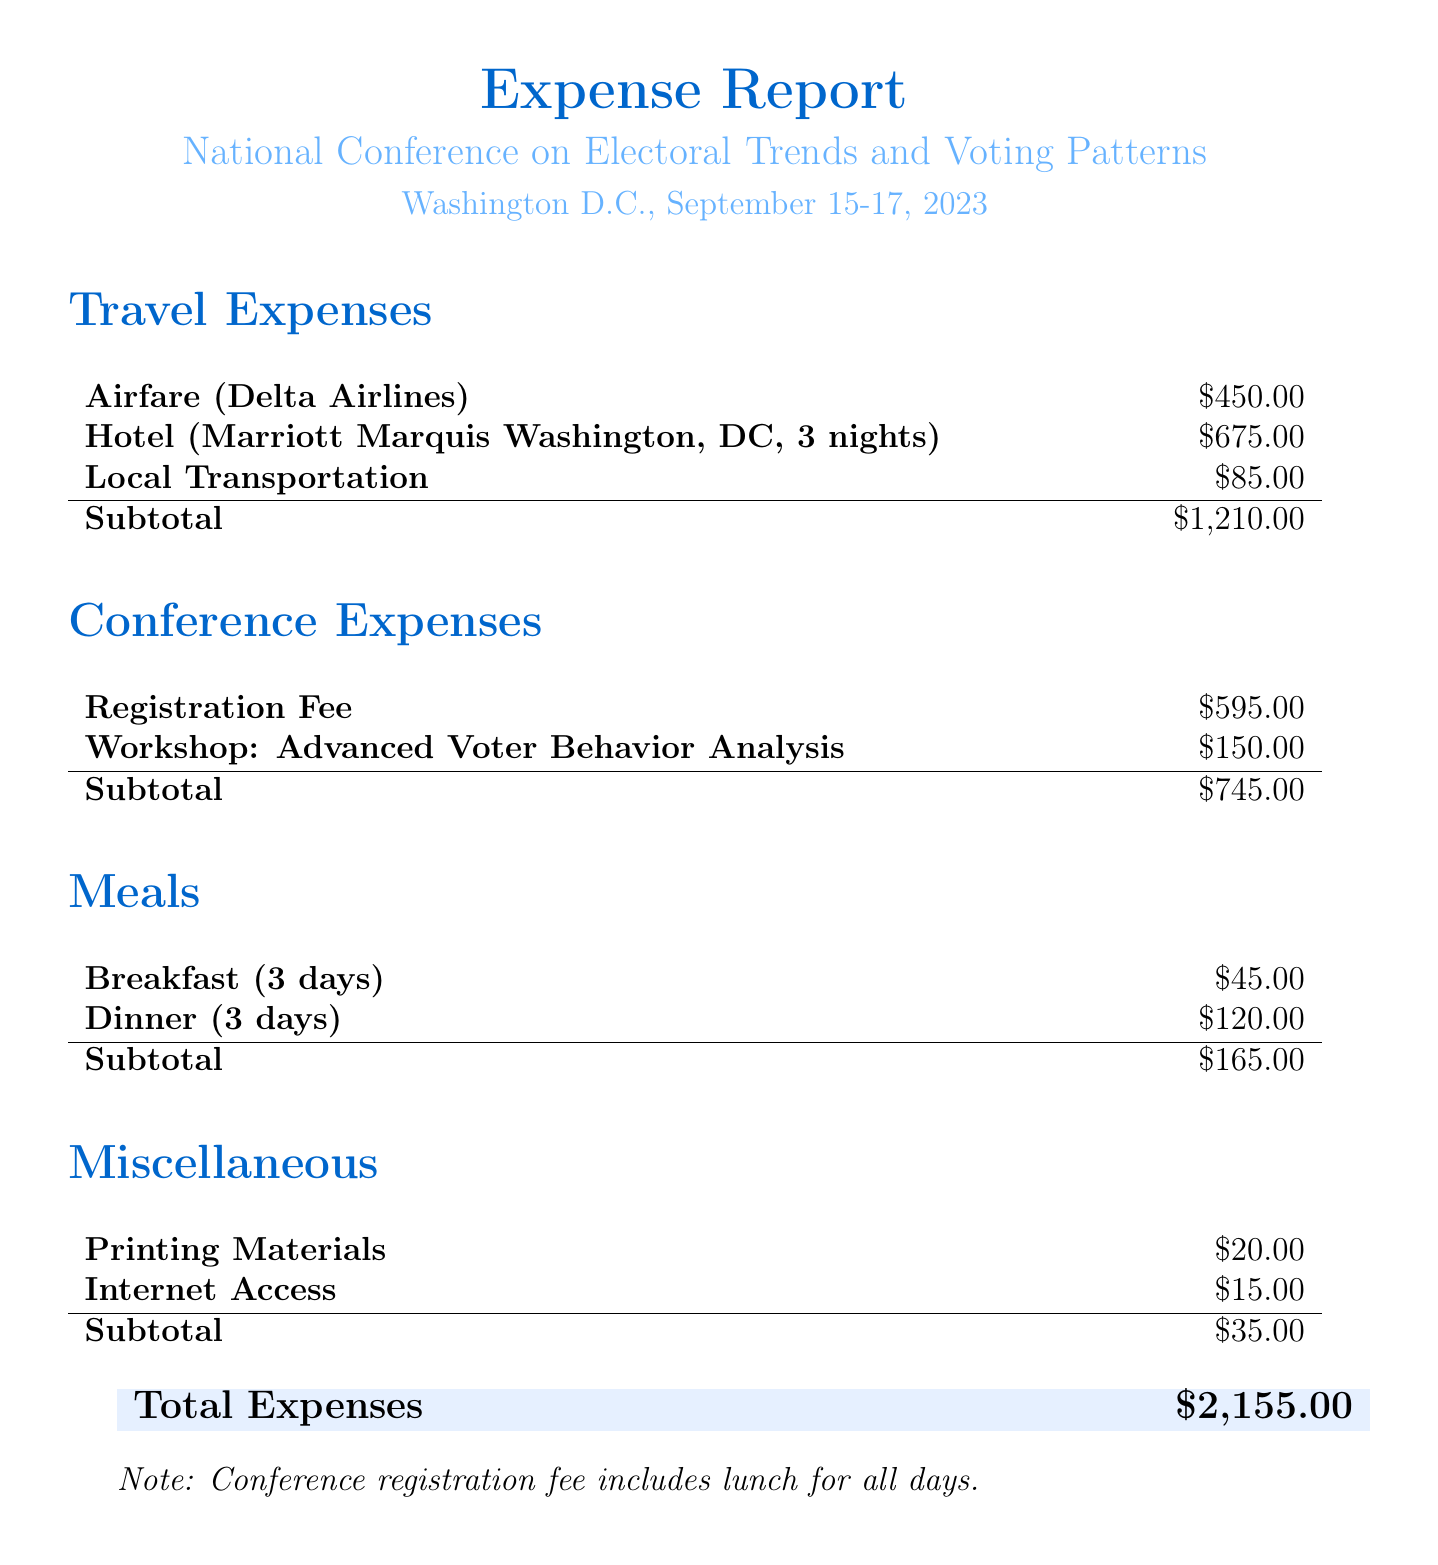what is the name of the conference? The name of the conference is provided in the document as "National Conference on Electoral Trends and Voting Patterns."
Answer: National Conference on Electoral Trends and Voting Patterns where is the conference located? The location of the conference is specified in the document as Washington D.C.
Answer: Washington D.C what are the dates of the conference? The document mentions the conference is from September 15-17, 2023.
Answer: September 15-17, 2023 what was the cost of the airfare? The airfare cost listed in the document is $450.00.
Answer: $450.00 what was the total cost for hotel accommodation? The document states the hotel cost is for 3 nights at $225.00 per night, totaling $675.00.
Answer: $675.00 how much was spent on meals in total? The meal expenses in the document are $165.00, calculated from breakfast and dinner costs.
Answer: $165.00 what is the total expense reported? The total expenses summarized in the document amount to $2,155.00.
Answer: $2,155.00 does the conference registration fee include lunch? The document notes that the registration fee includes lunch for all days.
Answer: Yes what was the cost of the professional development workshop? The document states that the workshop fee for "Advanced Voter Behavior Analysis" is $150.00.
Answer: $150.00 